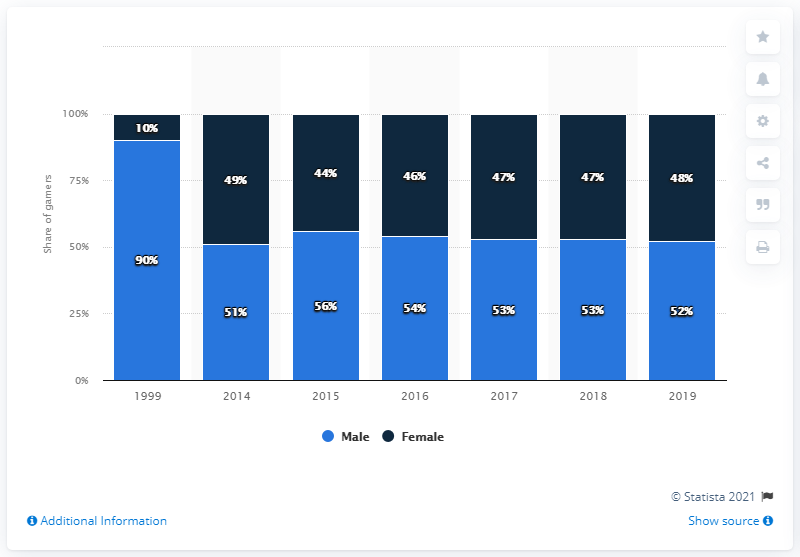Draw attention to some important aspects in this diagram. In 1999, the gender distribution of video gamers in France was (given the information provided). 